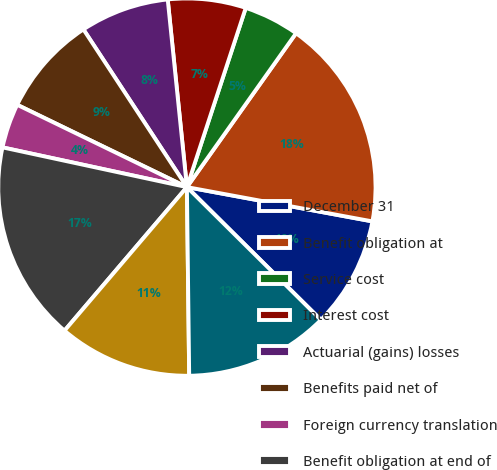Convert chart. <chart><loc_0><loc_0><loc_500><loc_500><pie_chart><fcel>December 31<fcel>Benefit obligation at<fcel>Service cost<fcel>Interest cost<fcel>Actuarial (gains) losses<fcel>Benefits paid net of<fcel>Foreign currency translation<fcel>Benefit obligation at end of<fcel>Funded status<fcel>Net funded status<nl><fcel>9.52%<fcel>18.09%<fcel>4.77%<fcel>6.67%<fcel>7.62%<fcel>8.57%<fcel>3.81%<fcel>17.14%<fcel>11.43%<fcel>12.38%<nl></chart> 